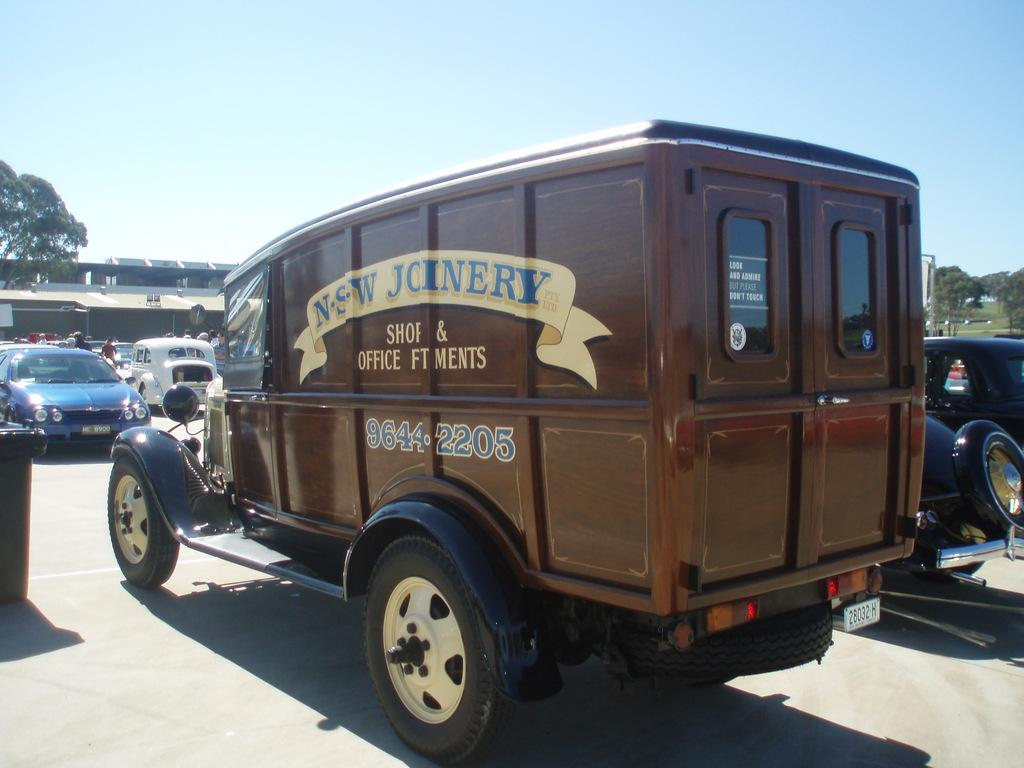What can be seen on the road in the image? There are vehicles on the road in the image. Who or what can be seen in the image besides the vehicles? There are people visible in the image. What type of structures are present in the image? Rooftops are present in the image. What object can be seen in the image that might contain information or a message? There is a board in the image. What type of natural environment is visible in the image? Grass and trees are visible in the image. What is visible in the background of the image? The sky is visible in the background of the image. Can you tell me how many stamps are on the board in the image? There is no mention of stamps in the image; the board might contain information or a message, but not stamps. What type of tramp is visible in the image? There is no tramp present in the image; it features vehicles, people, rooftops, a board, grass, trees, and the sky. 